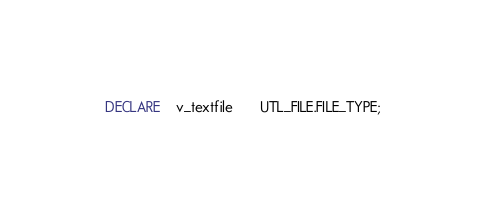<code> <loc_0><loc_0><loc_500><loc_500><_SQL_>  DECLARE    v_textfile       UTL_FILE.FILE_TYPE;</code> 